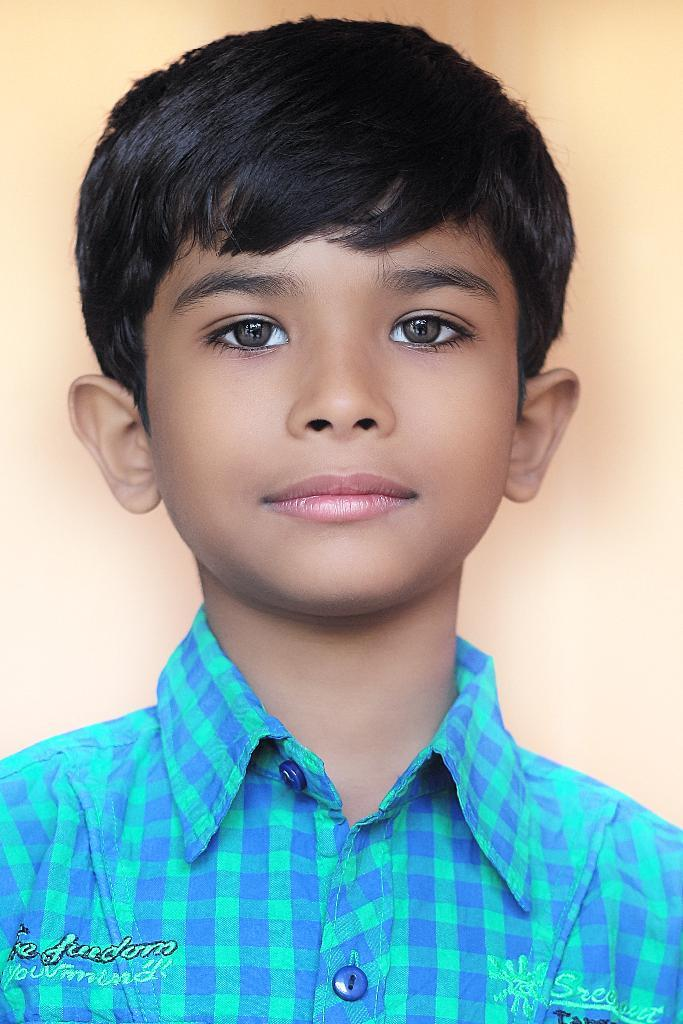What is the main subject of the image? The main subject of the image is a photo of a person. Can you describe the person's appearance in the photo? The person in the photo has text on their shirt. What type of canvas is the person holding in the image? There is no canvas present in the image; it only features a photo of a person with text on their shirt. What kind of pet can be seen in the image? There is no pet visible in the image. 